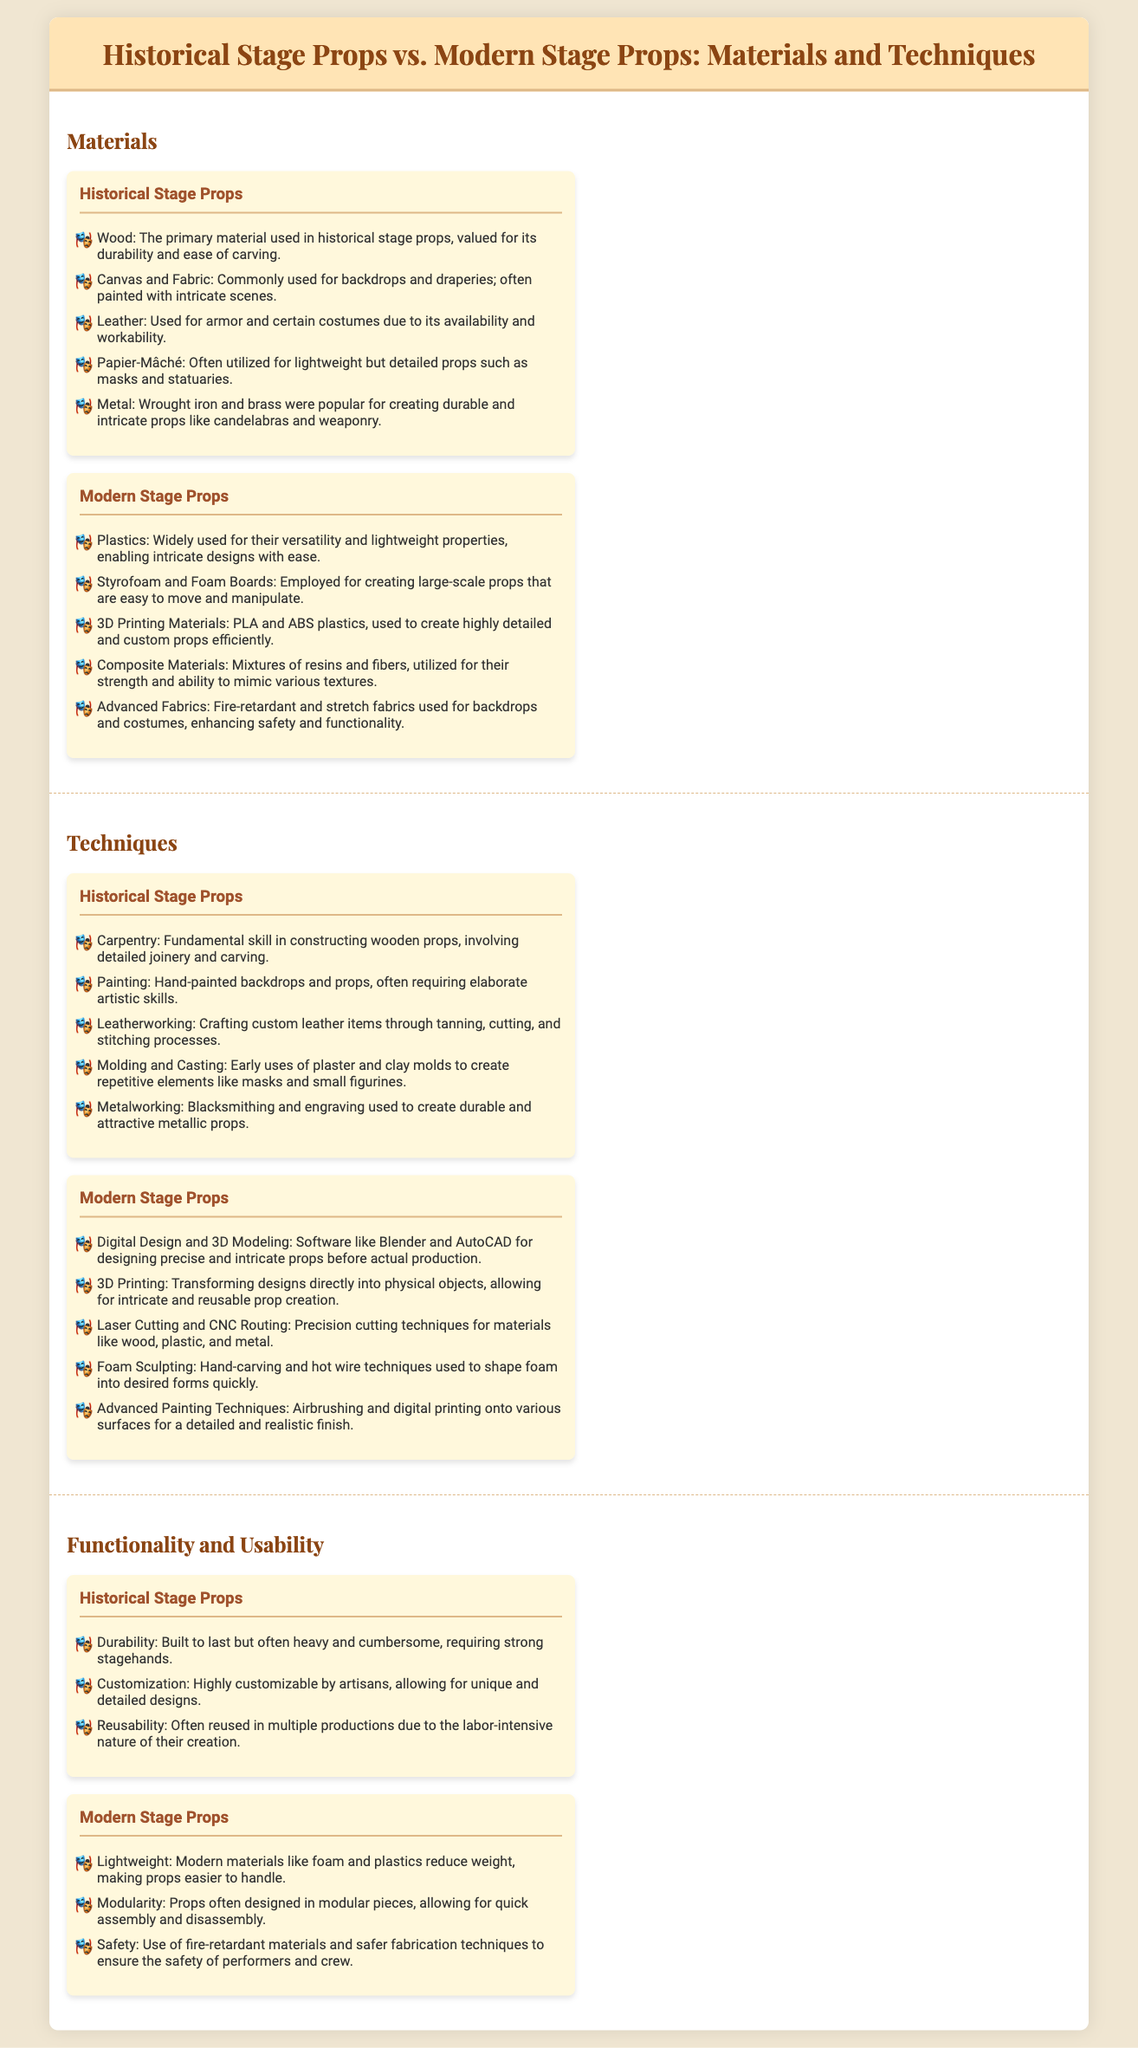What was the primary material used in historical stage props? The document states that wood was the primary material used in historical stage props, valued for its durability and ease of carving.
Answer: Wood Which modern material is used for creating large-scale props that are easy to move? The document mentions Styrofoam and foam boards as materials employed for creating large-scale props that are easy to move and manipulate.
Answer: Styrofoam and Foam Boards What is a technique unique to modern stage props? The infographic lists digital design and 3D modeling as a modern technique that allows for precise and intricate designs before actual production.
Answer: Digital Design and 3D Modeling How were historical stage props commonly customized? According to the document, historical stage props were highly customizable by artisans, allowing for unique and detailed designs.
Answer: Highly customizable Which category of props is described as lightweight? The document mentions that modern stage props made of modern materials like foam and plastics are described as lightweight, making them easier to handle.
Answer: Modern stage props What is an example of an advanced modern painting technique? The document lists airbrushing as an advanced painting technique used in modern stage props for a detailed and realistic finish.
Answer: Airbrushing How does the reusability of historical stage props compare to modern stage props? The document indicates that historical stage props were often reused in multiple productions due to their labor-intensive creation, whereas modern stage props focus more on lightweight and modular designs.
Answer: Often reused What is a common technique used in historical stage props for creating repetitive elements? According to the document, molding and casting were used in historical stage props to create repetitive elements like masks and small figurines.
Answer: Molding and Casting What type of materials enhance safety in modern stage props? The document states that the use of fire-retardant materials in modern stage props is critical for ensuring the safety of performers and crew.
Answer: Fire-retardant materials 